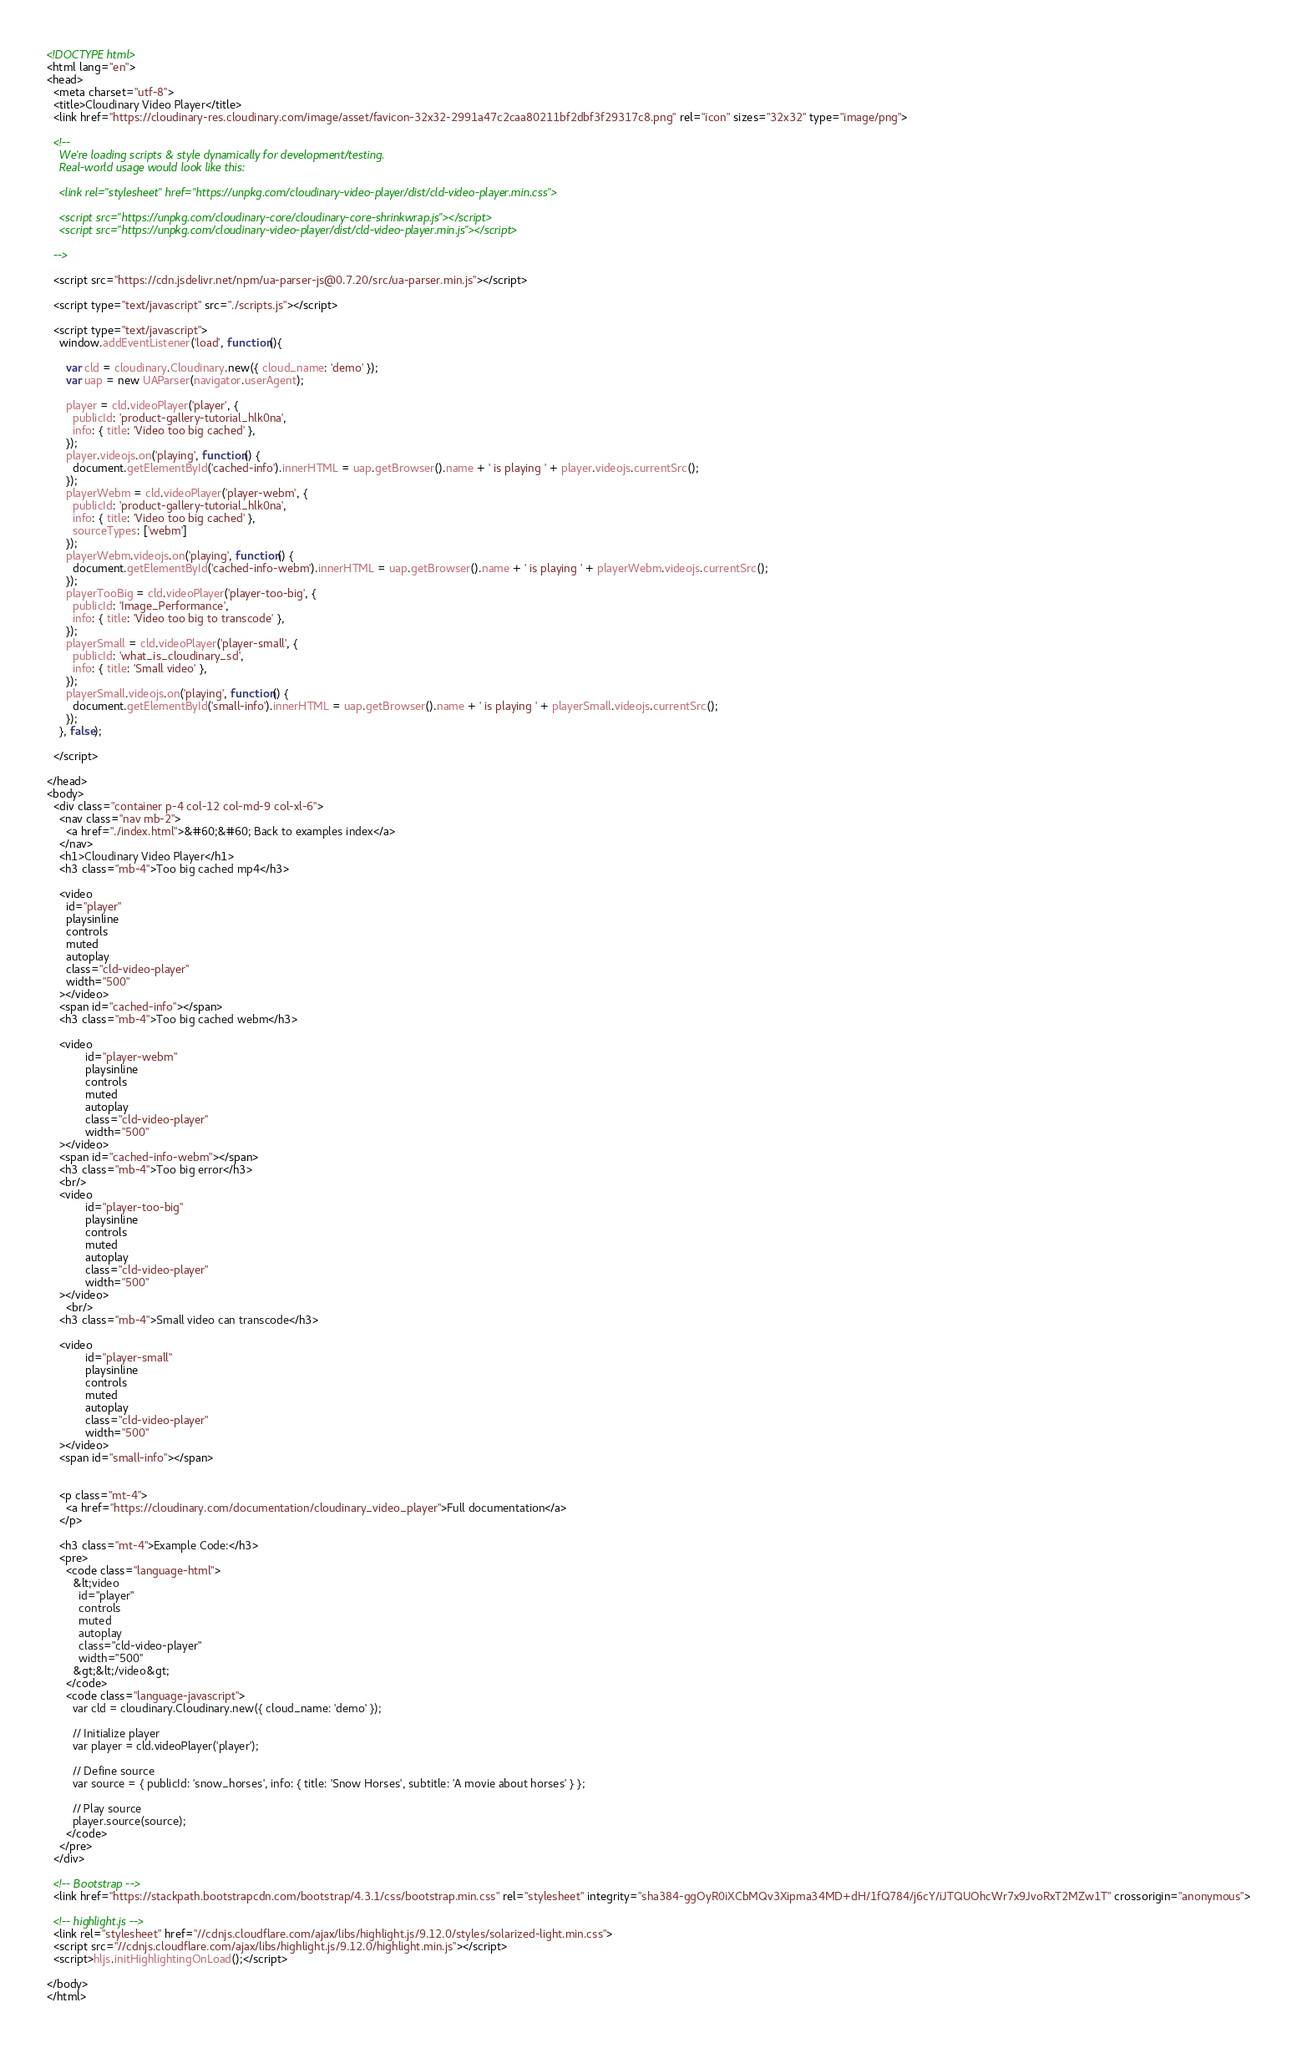Convert code to text. <code><loc_0><loc_0><loc_500><loc_500><_HTML_><!DOCTYPE html>
<html lang="en">
<head>
  <meta charset="utf-8">
  <title>Cloudinary Video Player</title>
  <link href="https://cloudinary-res.cloudinary.com/image/asset/favicon-32x32-2991a47c2caa80211bf2dbf3f29317c8.png" rel="icon" sizes="32x32" type="image/png">

  <!--
    We're loading scripts & style dynamically for development/testing.
    Real-world usage would look like this:

    <link rel="stylesheet" href="https://unpkg.com/cloudinary-video-player/dist/cld-video-player.min.css">

    <script src="https://unpkg.com/cloudinary-core/cloudinary-core-shrinkwrap.js"></script>
    <script src="https://unpkg.com/cloudinary-video-player/dist/cld-video-player.min.js"></script>

  -->

  <script src="https://cdn.jsdelivr.net/npm/ua-parser-js@0.7.20/src/ua-parser.min.js"></script>

  <script type="text/javascript" src="./scripts.js"></script>

  <script type="text/javascript">
    window.addEventListener('load', function(){

      var cld = cloudinary.Cloudinary.new({ cloud_name: 'demo' });
      var uap = new UAParser(navigator.userAgent);

      player = cld.videoPlayer('player', {
        publicId: 'product-gallery-tutorial_hlk0na',
        info: { title: 'Video too big cached' },
      });
      player.videojs.on('playing', function() {
        document.getElementById('cached-info').innerHTML = uap.getBrowser().name + ' is playing ' + player.videojs.currentSrc();
      });
      playerWebm = cld.videoPlayer('player-webm', {
        publicId: 'product-gallery-tutorial_hlk0na',
        info: { title: 'Video too big cached' },
        sourceTypes: ['webm']
      });
      playerWebm.videojs.on('playing', function() {
        document.getElementById('cached-info-webm').innerHTML = uap.getBrowser().name + ' is playing ' + playerWebm.videojs.currentSrc();
      });
      playerTooBig = cld.videoPlayer('player-too-big', {
        publicId: 'Image_Performance',
        info: { title: 'Video too big to transcode' },
      });
      playerSmall = cld.videoPlayer('player-small', {
        publicId: 'what_is_cloudinary_sd',
        info: { title: 'Small video' },
      });
      playerSmall.videojs.on('playing', function() {
        document.getElementById('small-info').innerHTML = uap.getBrowser().name + ' is playing ' + playerSmall.videojs.currentSrc();
      });
    }, false);

  </script>

</head>
<body>
  <div class="container p-4 col-12 col-md-9 col-xl-6">
    <nav class="nav mb-2">
      <a href="./index.html">&#60;&#60; Back to examples index</a>
    </nav>
    <h1>Cloudinary Video Player</h1>
    <h3 class="mb-4">Too big cached mp4</h3>

    <video
      id="player"
      playsinline
      controls
      muted
      autoplay
      class="cld-video-player"
      width="500"
    ></video>
    <span id="cached-info"></span>
    <h3 class="mb-4">Too big cached webm</h3>

    <video
            id="player-webm"
            playsinline
            controls
            muted
            autoplay
            class="cld-video-player"
            width="500"
    ></video>
    <span id="cached-info-webm"></span>
    <h3 class="mb-4">Too big error</h3>
    <br/>
    <video
            id="player-too-big"
            playsinline
            controls
            muted
            autoplay
            class="cld-video-player"
            width="500"
    ></video>
      <br/>
    <h3 class="mb-4">Small video can transcode</h3>

    <video
            id="player-small"
            playsinline
            controls
            muted
            autoplay
            class="cld-video-player"
            width="500"
    ></video>
    <span id="small-info"></span>


    <p class="mt-4">
      <a href="https://cloudinary.com/documentation/cloudinary_video_player">Full documentation</a>
    </p>

    <h3 class="mt-4">Example Code:</h3>
    <pre>
      <code class="language-html">
        &lt;video
          id="player"
          controls
          muted
          autoplay
          class="cld-video-player"
          width="500"
        &gt;&lt;/video&gt;
      </code>
      <code class="language-javascript">
        var cld = cloudinary.Cloudinary.new({ cloud_name: 'demo' });

        // Initialize player
        var player = cld.videoPlayer('player');

        // Define source
        var source = { publicId: 'snow_horses', info: { title: 'Snow Horses', subtitle: 'A movie about horses' } };

        // Play source
        player.source(source);
      </code>
    </pre>
  </div>

  <!-- Bootstrap -->
  <link href="https://stackpath.bootstrapcdn.com/bootstrap/4.3.1/css/bootstrap.min.css" rel="stylesheet" integrity="sha384-ggOyR0iXCbMQv3Xipma34MD+dH/1fQ784/j6cY/iJTQUOhcWr7x9JvoRxT2MZw1T" crossorigin="anonymous">

  <!-- highlight.js -->
  <link rel="stylesheet" href="//cdnjs.cloudflare.com/ajax/libs/highlight.js/9.12.0/styles/solarized-light.min.css">
  <script src="//cdnjs.cloudflare.com/ajax/libs/highlight.js/9.12.0/highlight.min.js"></script>
  <script>hljs.initHighlightingOnLoad();</script>

</body>
</html>
</code> 